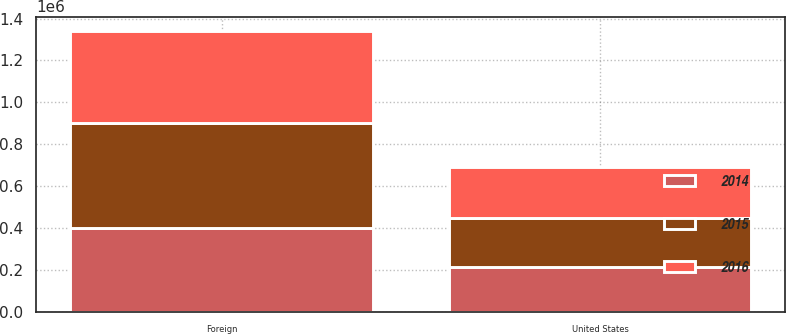<chart> <loc_0><loc_0><loc_500><loc_500><stacked_bar_chart><ecel><fcel>United States<fcel>Foreign<nl><fcel>2016<fcel>243754<fcel>443102<nl><fcel>2015<fcel>236932<fcel>499757<nl><fcel>2014<fcel>211588<fcel>399301<nl></chart> 